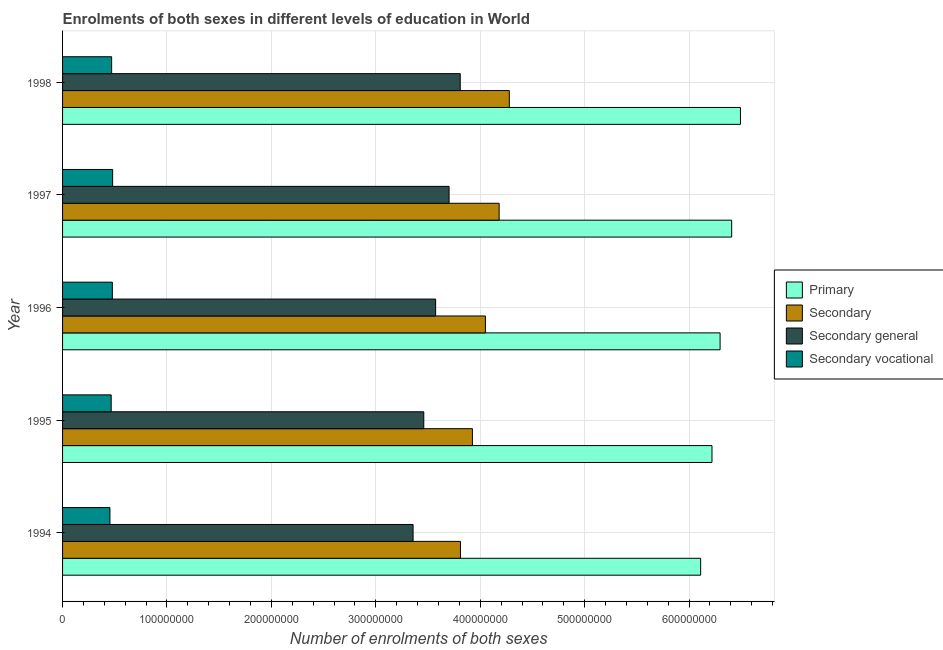Are the number of bars per tick equal to the number of legend labels?
Offer a very short reply. Yes. Are the number of bars on each tick of the Y-axis equal?
Offer a terse response. Yes. In how many cases, is the number of bars for a given year not equal to the number of legend labels?
Give a very brief answer. 0. What is the number of enrolments in primary education in 1996?
Provide a succinct answer. 6.30e+08. Across all years, what is the maximum number of enrolments in primary education?
Your answer should be compact. 6.49e+08. Across all years, what is the minimum number of enrolments in primary education?
Provide a succinct answer. 6.11e+08. What is the total number of enrolments in secondary vocational education in the graph?
Provide a short and direct response. 2.35e+08. What is the difference between the number of enrolments in primary education in 1994 and that in 1996?
Your answer should be compact. -1.86e+07. What is the difference between the number of enrolments in primary education in 1994 and the number of enrolments in secondary general education in 1998?
Provide a short and direct response. 2.30e+08. What is the average number of enrolments in secondary education per year?
Ensure brevity in your answer.  4.05e+08. In the year 1995, what is the difference between the number of enrolments in secondary education and number of enrolments in secondary general education?
Make the answer very short. 4.66e+07. In how many years, is the number of enrolments in secondary education greater than 260000000 ?
Keep it short and to the point. 5. Is the number of enrolments in secondary education in 1995 less than that in 1996?
Your answer should be very brief. Yes. What is the difference between the highest and the second highest number of enrolments in secondary vocational education?
Provide a short and direct response. 2.77e+05. What is the difference between the highest and the lowest number of enrolments in secondary general education?
Keep it short and to the point. 4.52e+07. In how many years, is the number of enrolments in secondary general education greater than the average number of enrolments in secondary general education taken over all years?
Give a very brief answer. 2. Is the sum of the number of enrolments in secondary general education in 1994 and 1997 greater than the maximum number of enrolments in secondary education across all years?
Give a very brief answer. Yes. Is it the case that in every year, the sum of the number of enrolments in secondary education and number of enrolments in secondary vocational education is greater than the sum of number of enrolments in secondary general education and number of enrolments in primary education?
Provide a succinct answer. Yes. What does the 4th bar from the top in 1994 represents?
Your answer should be very brief. Primary. What does the 3rd bar from the bottom in 1997 represents?
Your answer should be very brief. Secondary general. How many bars are there?
Your response must be concise. 20. Are all the bars in the graph horizontal?
Give a very brief answer. Yes. Are the values on the major ticks of X-axis written in scientific E-notation?
Your answer should be compact. No. Where does the legend appear in the graph?
Provide a succinct answer. Center right. How many legend labels are there?
Make the answer very short. 4. How are the legend labels stacked?
Your answer should be very brief. Vertical. What is the title of the graph?
Ensure brevity in your answer.  Enrolments of both sexes in different levels of education in World. Does "UNPBF" appear as one of the legend labels in the graph?
Provide a short and direct response. No. What is the label or title of the X-axis?
Make the answer very short. Number of enrolments of both sexes. What is the label or title of the Y-axis?
Provide a succinct answer. Year. What is the Number of enrolments of both sexes in Primary in 1994?
Your answer should be compact. 6.11e+08. What is the Number of enrolments of both sexes of Secondary in 1994?
Provide a short and direct response. 3.81e+08. What is the Number of enrolments of both sexes in Secondary general in 1994?
Ensure brevity in your answer.  3.36e+08. What is the Number of enrolments of both sexes of Secondary vocational in 1994?
Offer a terse response. 4.54e+07. What is the Number of enrolments of both sexes in Primary in 1995?
Offer a terse response. 6.22e+08. What is the Number of enrolments of both sexes of Secondary in 1995?
Your response must be concise. 3.92e+08. What is the Number of enrolments of both sexes of Secondary general in 1995?
Make the answer very short. 3.46e+08. What is the Number of enrolments of both sexes in Secondary vocational in 1995?
Make the answer very short. 4.66e+07. What is the Number of enrolments of both sexes of Primary in 1996?
Give a very brief answer. 6.30e+08. What is the Number of enrolments of both sexes of Secondary in 1996?
Your answer should be compact. 4.05e+08. What is the Number of enrolments of both sexes in Secondary general in 1996?
Offer a terse response. 3.57e+08. What is the Number of enrolments of both sexes in Secondary vocational in 1996?
Make the answer very short. 4.77e+07. What is the Number of enrolments of both sexes of Primary in 1997?
Offer a very short reply. 6.41e+08. What is the Number of enrolments of both sexes of Secondary in 1997?
Make the answer very short. 4.18e+08. What is the Number of enrolments of both sexes of Secondary general in 1997?
Give a very brief answer. 3.70e+08. What is the Number of enrolments of both sexes of Secondary vocational in 1997?
Keep it short and to the point. 4.80e+07. What is the Number of enrolments of both sexes of Primary in 1998?
Provide a short and direct response. 6.49e+08. What is the Number of enrolments of both sexes of Secondary in 1998?
Your answer should be compact. 4.28e+08. What is the Number of enrolments of both sexes in Secondary general in 1998?
Provide a short and direct response. 3.81e+08. What is the Number of enrolments of both sexes in Secondary vocational in 1998?
Your response must be concise. 4.70e+07. Across all years, what is the maximum Number of enrolments of both sexes in Primary?
Provide a short and direct response. 6.49e+08. Across all years, what is the maximum Number of enrolments of both sexes of Secondary?
Your answer should be compact. 4.28e+08. Across all years, what is the maximum Number of enrolments of both sexes in Secondary general?
Offer a very short reply. 3.81e+08. Across all years, what is the maximum Number of enrolments of both sexes in Secondary vocational?
Offer a terse response. 4.80e+07. Across all years, what is the minimum Number of enrolments of both sexes in Primary?
Ensure brevity in your answer.  6.11e+08. Across all years, what is the minimum Number of enrolments of both sexes in Secondary?
Your answer should be compact. 3.81e+08. Across all years, what is the minimum Number of enrolments of both sexes of Secondary general?
Offer a very short reply. 3.36e+08. Across all years, what is the minimum Number of enrolments of both sexes of Secondary vocational?
Make the answer very short. 4.54e+07. What is the total Number of enrolments of both sexes in Primary in the graph?
Provide a short and direct response. 3.15e+09. What is the total Number of enrolments of both sexes of Secondary in the graph?
Your answer should be very brief. 2.02e+09. What is the total Number of enrolments of both sexes in Secondary general in the graph?
Make the answer very short. 1.79e+09. What is the total Number of enrolments of both sexes in Secondary vocational in the graph?
Make the answer very short. 2.35e+08. What is the difference between the Number of enrolments of both sexes of Primary in 1994 and that in 1995?
Offer a very short reply. -1.08e+07. What is the difference between the Number of enrolments of both sexes in Secondary in 1994 and that in 1995?
Your answer should be compact. -1.14e+07. What is the difference between the Number of enrolments of both sexes in Secondary general in 1994 and that in 1995?
Offer a terse response. -1.02e+07. What is the difference between the Number of enrolments of both sexes of Secondary vocational in 1994 and that in 1995?
Give a very brief answer. -1.20e+06. What is the difference between the Number of enrolments of both sexes in Primary in 1994 and that in 1996?
Ensure brevity in your answer.  -1.86e+07. What is the difference between the Number of enrolments of both sexes in Secondary in 1994 and that in 1996?
Provide a short and direct response. -2.39e+07. What is the difference between the Number of enrolments of both sexes in Secondary general in 1994 and that in 1996?
Your answer should be compact. -2.16e+07. What is the difference between the Number of enrolments of both sexes of Secondary vocational in 1994 and that in 1996?
Provide a short and direct response. -2.31e+06. What is the difference between the Number of enrolments of both sexes of Primary in 1994 and that in 1997?
Provide a succinct answer. -2.97e+07. What is the difference between the Number of enrolments of both sexes of Secondary in 1994 and that in 1997?
Your answer should be compact. -3.71e+07. What is the difference between the Number of enrolments of both sexes of Secondary general in 1994 and that in 1997?
Offer a very short reply. -3.45e+07. What is the difference between the Number of enrolments of both sexes of Secondary vocational in 1994 and that in 1997?
Your answer should be compact. -2.59e+06. What is the difference between the Number of enrolments of both sexes in Primary in 1994 and that in 1998?
Offer a very short reply. -3.81e+07. What is the difference between the Number of enrolments of both sexes in Secondary in 1994 and that in 1998?
Give a very brief answer. -4.68e+07. What is the difference between the Number of enrolments of both sexes in Secondary general in 1994 and that in 1998?
Give a very brief answer. -4.52e+07. What is the difference between the Number of enrolments of both sexes of Secondary vocational in 1994 and that in 1998?
Offer a very short reply. -1.64e+06. What is the difference between the Number of enrolments of both sexes of Primary in 1995 and that in 1996?
Your response must be concise. -7.77e+06. What is the difference between the Number of enrolments of both sexes in Secondary in 1995 and that in 1996?
Offer a very short reply. -1.25e+07. What is the difference between the Number of enrolments of both sexes of Secondary general in 1995 and that in 1996?
Ensure brevity in your answer.  -1.14e+07. What is the difference between the Number of enrolments of both sexes of Secondary vocational in 1995 and that in 1996?
Ensure brevity in your answer.  -1.12e+06. What is the difference between the Number of enrolments of both sexes of Primary in 1995 and that in 1997?
Your response must be concise. -1.89e+07. What is the difference between the Number of enrolments of both sexes of Secondary in 1995 and that in 1997?
Make the answer very short. -2.56e+07. What is the difference between the Number of enrolments of both sexes of Secondary general in 1995 and that in 1997?
Your answer should be very brief. -2.42e+07. What is the difference between the Number of enrolments of both sexes of Secondary vocational in 1995 and that in 1997?
Your answer should be compact. -1.39e+06. What is the difference between the Number of enrolments of both sexes in Primary in 1995 and that in 1998?
Your response must be concise. -2.73e+07. What is the difference between the Number of enrolments of both sexes in Secondary in 1995 and that in 1998?
Your answer should be compact. -3.53e+07. What is the difference between the Number of enrolments of both sexes in Secondary general in 1995 and that in 1998?
Offer a very short reply. -3.49e+07. What is the difference between the Number of enrolments of both sexes in Secondary vocational in 1995 and that in 1998?
Give a very brief answer. -4.42e+05. What is the difference between the Number of enrolments of both sexes of Primary in 1996 and that in 1997?
Ensure brevity in your answer.  -1.11e+07. What is the difference between the Number of enrolments of both sexes of Secondary in 1996 and that in 1997?
Your answer should be very brief. -1.31e+07. What is the difference between the Number of enrolments of both sexes in Secondary general in 1996 and that in 1997?
Keep it short and to the point. -1.29e+07. What is the difference between the Number of enrolments of both sexes in Secondary vocational in 1996 and that in 1997?
Your answer should be very brief. -2.77e+05. What is the difference between the Number of enrolments of both sexes of Primary in 1996 and that in 1998?
Offer a terse response. -1.95e+07. What is the difference between the Number of enrolments of both sexes in Secondary in 1996 and that in 1998?
Ensure brevity in your answer.  -2.29e+07. What is the difference between the Number of enrolments of both sexes of Secondary general in 1996 and that in 1998?
Offer a terse response. -2.35e+07. What is the difference between the Number of enrolments of both sexes of Secondary vocational in 1996 and that in 1998?
Ensure brevity in your answer.  6.76e+05. What is the difference between the Number of enrolments of both sexes of Primary in 1997 and that in 1998?
Your answer should be very brief. -8.42e+06. What is the difference between the Number of enrolments of both sexes of Secondary in 1997 and that in 1998?
Give a very brief answer. -9.73e+06. What is the difference between the Number of enrolments of both sexes in Secondary general in 1997 and that in 1998?
Your answer should be very brief. -1.07e+07. What is the difference between the Number of enrolments of both sexes in Secondary vocational in 1997 and that in 1998?
Provide a short and direct response. 9.53e+05. What is the difference between the Number of enrolments of both sexes in Primary in 1994 and the Number of enrolments of both sexes in Secondary in 1995?
Your answer should be very brief. 2.19e+08. What is the difference between the Number of enrolments of both sexes in Primary in 1994 and the Number of enrolments of both sexes in Secondary general in 1995?
Ensure brevity in your answer.  2.65e+08. What is the difference between the Number of enrolments of both sexes in Primary in 1994 and the Number of enrolments of both sexes in Secondary vocational in 1995?
Keep it short and to the point. 5.65e+08. What is the difference between the Number of enrolments of both sexes in Secondary in 1994 and the Number of enrolments of both sexes in Secondary general in 1995?
Provide a succinct answer. 3.51e+07. What is the difference between the Number of enrolments of both sexes in Secondary in 1994 and the Number of enrolments of both sexes in Secondary vocational in 1995?
Provide a short and direct response. 3.34e+08. What is the difference between the Number of enrolments of both sexes in Secondary general in 1994 and the Number of enrolments of both sexes in Secondary vocational in 1995?
Provide a succinct answer. 2.89e+08. What is the difference between the Number of enrolments of both sexes in Primary in 1994 and the Number of enrolments of both sexes in Secondary in 1996?
Make the answer very short. 2.06e+08. What is the difference between the Number of enrolments of both sexes in Primary in 1994 and the Number of enrolments of both sexes in Secondary general in 1996?
Your response must be concise. 2.54e+08. What is the difference between the Number of enrolments of both sexes of Primary in 1994 and the Number of enrolments of both sexes of Secondary vocational in 1996?
Your answer should be compact. 5.63e+08. What is the difference between the Number of enrolments of both sexes of Secondary in 1994 and the Number of enrolments of both sexes of Secondary general in 1996?
Provide a short and direct response. 2.38e+07. What is the difference between the Number of enrolments of both sexes of Secondary in 1994 and the Number of enrolments of both sexes of Secondary vocational in 1996?
Make the answer very short. 3.33e+08. What is the difference between the Number of enrolments of both sexes of Secondary general in 1994 and the Number of enrolments of both sexes of Secondary vocational in 1996?
Give a very brief answer. 2.88e+08. What is the difference between the Number of enrolments of both sexes of Primary in 1994 and the Number of enrolments of both sexes of Secondary in 1997?
Make the answer very short. 1.93e+08. What is the difference between the Number of enrolments of both sexes of Primary in 1994 and the Number of enrolments of both sexes of Secondary general in 1997?
Keep it short and to the point. 2.41e+08. What is the difference between the Number of enrolments of both sexes of Primary in 1994 and the Number of enrolments of both sexes of Secondary vocational in 1997?
Ensure brevity in your answer.  5.63e+08. What is the difference between the Number of enrolments of both sexes in Secondary in 1994 and the Number of enrolments of both sexes in Secondary general in 1997?
Your answer should be compact. 1.09e+07. What is the difference between the Number of enrolments of both sexes of Secondary in 1994 and the Number of enrolments of both sexes of Secondary vocational in 1997?
Provide a succinct answer. 3.33e+08. What is the difference between the Number of enrolments of both sexes in Secondary general in 1994 and the Number of enrolments of both sexes in Secondary vocational in 1997?
Provide a succinct answer. 2.88e+08. What is the difference between the Number of enrolments of both sexes in Primary in 1994 and the Number of enrolments of both sexes in Secondary in 1998?
Your answer should be very brief. 1.83e+08. What is the difference between the Number of enrolments of both sexes of Primary in 1994 and the Number of enrolments of both sexes of Secondary general in 1998?
Your answer should be compact. 2.30e+08. What is the difference between the Number of enrolments of both sexes in Primary in 1994 and the Number of enrolments of both sexes in Secondary vocational in 1998?
Give a very brief answer. 5.64e+08. What is the difference between the Number of enrolments of both sexes in Secondary in 1994 and the Number of enrolments of both sexes in Secondary general in 1998?
Make the answer very short. 2.07e+05. What is the difference between the Number of enrolments of both sexes in Secondary in 1994 and the Number of enrolments of both sexes in Secondary vocational in 1998?
Keep it short and to the point. 3.34e+08. What is the difference between the Number of enrolments of both sexes of Secondary general in 1994 and the Number of enrolments of both sexes of Secondary vocational in 1998?
Give a very brief answer. 2.89e+08. What is the difference between the Number of enrolments of both sexes of Primary in 1995 and the Number of enrolments of both sexes of Secondary in 1996?
Keep it short and to the point. 2.17e+08. What is the difference between the Number of enrolments of both sexes in Primary in 1995 and the Number of enrolments of both sexes in Secondary general in 1996?
Provide a succinct answer. 2.65e+08. What is the difference between the Number of enrolments of both sexes of Primary in 1995 and the Number of enrolments of both sexes of Secondary vocational in 1996?
Ensure brevity in your answer.  5.74e+08. What is the difference between the Number of enrolments of both sexes in Secondary in 1995 and the Number of enrolments of both sexes in Secondary general in 1996?
Make the answer very short. 3.52e+07. What is the difference between the Number of enrolments of both sexes in Secondary in 1995 and the Number of enrolments of both sexes in Secondary vocational in 1996?
Provide a short and direct response. 3.45e+08. What is the difference between the Number of enrolments of both sexes of Secondary general in 1995 and the Number of enrolments of both sexes of Secondary vocational in 1996?
Make the answer very short. 2.98e+08. What is the difference between the Number of enrolments of both sexes of Primary in 1995 and the Number of enrolments of both sexes of Secondary in 1997?
Give a very brief answer. 2.04e+08. What is the difference between the Number of enrolments of both sexes of Primary in 1995 and the Number of enrolments of both sexes of Secondary general in 1997?
Provide a succinct answer. 2.52e+08. What is the difference between the Number of enrolments of both sexes in Primary in 1995 and the Number of enrolments of both sexes in Secondary vocational in 1997?
Give a very brief answer. 5.74e+08. What is the difference between the Number of enrolments of both sexes in Secondary in 1995 and the Number of enrolments of both sexes in Secondary general in 1997?
Offer a terse response. 2.23e+07. What is the difference between the Number of enrolments of both sexes of Secondary in 1995 and the Number of enrolments of both sexes of Secondary vocational in 1997?
Offer a terse response. 3.45e+08. What is the difference between the Number of enrolments of both sexes in Secondary general in 1995 and the Number of enrolments of both sexes in Secondary vocational in 1997?
Give a very brief answer. 2.98e+08. What is the difference between the Number of enrolments of both sexes in Primary in 1995 and the Number of enrolments of both sexes in Secondary in 1998?
Keep it short and to the point. 1.94e+08. What is the difference between the Number of enrolments of both sexes of Primary in 1995 and the Number of enrolments of both sexes of Secondary general in 1998?
Your answer should be compact. 2.41e+08. What is the difference between the Number of enrolments of both sexes of Primary in 1995 and the Number of enrolments of both sexes of Secondary vocational in 1998?
Your answer should be compact. 5.75e+08. What is the difference between the Number of enrolments of both sexes of Secondary in 1995 and the Number of enrolments of both sexes of Secondary general in 1998?
Provide a short and direct response. 1.17e+07. What is the difference between the Number of enrolments of both sexes of Secondary in 1995 and the Number of enrolments of both sexes of Secondary vocational in 1998?
Keep it short and to the point. 3.45e+08. What is the difference between the Number of enrolments of both sexes of Secondary general in 1995 and the Number of enrolments of both sexes of Secondary vocational in 1998?
Ensure brevity in your answer.  2.99e+08. What is the difference between the Number of enrolments of both sexes of Primary in 1996 and the Number of enrolments of both sexes of Secondary in 1997?
Ensure brevity in your answer.  2.12e+08. What is the difference between the Number of enrolments of both sexes of Primary in 1996 and the Number of enrolments of both sexes of Secondary general in 1997?
Make the answer very short. 2.60e+08. What is the difference between the Number of enrolments of both sexes in Primary in 1996 and the Number of enrolments of both sexes in Secondary vocational in 1997?
Offer a terse response. 5.82e+08. What is the difference between the Number of enrolments of both sexes of Secondary in 1996 and the Number of enrolments of both sexes of Secondary general in 1997?
Make the answer very short. 3.48e+07. What is the difference between the Number of enrolments of both sexes of Secondary in 1996 and the Number of enrolments of both sexes of Secondary vocational in 1997?
Your response must be concise. 3.57e+08. What is the difference between the Number of enrolments of both sexes of Secondary general in 1996 and the Number of enrolments of both sexes of Secondary vocational in 1997?
Keep it short and to the point. 3.09e+08. What is the difference between the Number of enrolments of both sexes in Primary in 1996 and the Number of enrolments of both sexes in Secondary in 1998?
Keep it short and to the point. 2.02e+08. What is the difference between the Number of enrolments of both sexes of Primary in 1996 and the Number of enrolments of both sexes of Secondary general in 1998?
Your response must be concise. 2.49e+08. What is the difference between the Number of enrolments of both sexes of Primary in 1996 and the Number of enrolments of both sexes of Secondary vocational in 1998?
Keep it short and to the point. 5.83e+08. What is the difference between the Number of enrolments of both sexes of Secondary in 1996 and the Number of enrolments of both sexes of Secondary general in 1998?
Your answer should be compact. 2.41e+07. What is the difference between the Number of enrolments of both sexes of Secondary in 1996 and the Number of enrolments of both sexes of Secondary vocational in 1998?
Provide a short and direct response. 3.58e+08. What is the difference between the Number of enrolments of both sexes in Secondary general in 1996 and the Number of enrolments of both sexes in Secondary vocational in 1998?
Make the answer very short. 3.10e+08. What is the difference between the Number of enrolments of both sexes of Primary in 1997 and the Number of enrolments of both sexes of Secondary in 1998?
Make the answer very short. 2.13e+08. What is the difference between the Number of enrolments of both sexes of Primary in 1997 and the Number of enrolments of both sexes of Secondary general in 1998?
Give a very brief answer. 2.60e+08. What is the difference between the Number of enrolments of both sexes of Primary in 1997 and the Number of enrolments of both sexes of Secondary vocational in 1998?
Offer a terse response. 5.94e+08. What is the difference between the Number of enrolments of both sexes of Secondary in 1997 and the Number of enrolments of both sexes of Secondary general in 1998?
Provide a succinct answer. 3.73e+07. What is the difference between the Number of enrolments of both sexes in Secondary in 1997 and the Number of enrolments of both sexes in Secondary vocational in 1998?
Your answer should be compact. 3.71e+08. What is the difference between the Number of enrolments of both sexes in Secondary general in 1997 and the Number of enrolments of both sexes in Secondary vocational in 1998?
Give a very brief answer. 3.23e+08. What is the average Number of enrolments of both sexes of Primary per year?
Your answer should be very brief. 6.31e+08. What is the average Number of enrolments of both sexes in Secondary per year?
Your response must be concise. 4.05e+08. What is the average Number of enrolments of both sexes of Secondary general per year?
Provide a succinct answer. 3.58e+08. What is the average Number of enrolments of both sexes of Secondary vocational per year?
Keep it short and to the point. 4.69e+07. In the year 1994, what is the difference between the Number of enrolments of both sexes in Primary and Number of enrolments of both sexes in Secondary?
Offer a very short reply. 2.30e+08. In the year 1994, what is the difference between the Number of enrolments of both sexes in Primary and Number of enrolments of both sexes in Secondary general?
Make the answer very short. 2.75e+08. In the year 1994, what is the difference between the Number of enrolments of both sexes of Primary and Number of enrolments of both sexes of Secondary vocational?
Ensure brevity in your answer.  5.66e+08. In the year 1994, what is the difference between the Number of enrolments of both sexes in Secondary and Number of enrolments of both sexes in Secondary general?
Your response must be concise. 4.54e+07. In the year 1994, what is the difference between the Number of enrolments of both sexes of Secondary and Number of enrolments of both sexes of Secondary vocational?
Your answer should be very brief. 3.36e+08. In the year 1994, what is the difference between the Number of enrolments of both sexes of Secondary general and Number of enrolments of both sexes of Secondary vocational?
Offer a terse response. 2.90e+08. In the year 1995, what is the difference between the Number of enrolments of both sexes in Primary and Number of enrolments of both sexes in Secondary?
Offer a terse response. 2.29e+08. In the year 1995, what is the difference between the Number of enrolments of both sexes in Primary and Number of enrolments of both sexes in Secondary general?
Offer a very short reply. 2.76e+08. In the year 1995, what is the difference between the Number of enrolments of both sexes of Primary and Number of enrolments of both sexes of Secondary vocational?
Keep it short and to the point. 5.75e+08. In the year 1995, what is the difference between the Number of enrolments of both sexes in Secondary and Number of enrolments of both sexes in Secondary general?
Your answer should be compact. 4.66e+07. In the year 1995, what is the difference between the Number of enrolments of both sexes of Secondary and Number of enrolments of both sexes of Secondary vocational?
Your answer should be very brief. 3.46e+08. In the year 1995, what is the difference between the Number of enrolments of both sexes in Secondary general and Number of enrolments of both sexes in Secondary vocational?
Make the answer very short. 2.99e+08. In the year 1996, what is the difference between the Number of enrolments of both sexes of Primary and Number of enrolments of both sexes of Secondary?
Provide a short and direct response. 2.25e+08. In the year 1996, what is the difference between the Number of enrolments of both sexes of Primary and Number of enrolments of both sexes of Secondary general?
Your response must be concise. 2.72e+08. In the year 1996, what is the difference between the Number of enrolments of both sexes in Primary and Number of enrolments of both sexes in Secondary vocational?
Provide a short and direct response. 5.82e+08. In the year 1996, what is the difference between the Number of enrolments of both sexes in Secondary and Number of enrolments of both sexes in Secondary general?
Offer a very short reply. 4.77e+07. In the year 1996, what is the difference between the Number of enrolments of both sexes of Secondary and Number of enrolments of both sexes of Secondary vocational?
Provide a short and direct response. 3.57e+08. In the year 1996, what is the difference between the Number of enrolments of both sexes in Secondary general and Number of enrolments of both sexes in Secondary vocational?
Keep it short and to the point. 3.10e+08. In the year 1997, what is the difference between the Number of enrolments of both sexes of Primary and Number of enrolments of both sexes of Secondary?
Offer a terse response. 2.23e+08. In the year 1997, what is the difference between the Number of enrolments of both sexes in Primary and Number of enrolments of both sexes in Secondary general?
Offer a terse response. 2.71e+08. In the year 1997, what is the difference between the Number of enrolments of both sexes of Primary and Number of enrolments of both sexes of Secondary vocational?
Make the answer very short. 5.93e+08. In the year 1997, what is the difference between the Number of enrolments of both sexes of Secondary and Number of enrolments of both sexes of Secondary general?
Your response must be concise. 4.80e+07. In the year 1997, what is the difference between the Number of enrolments of both sexes in Secondary and Number of enrolments of both sexes in Secondary vocational?
Your response must be concise. 3.70e+08. In the year 1997, what is the difference between the Number of enrolments of both sexes of Secondary general and Number of enrolments of both sexes of Secondary vocational?
Provide a succinct answer. 3.22e+08. In the year 1998, what is the difference between the Number of enrolments of both sexes of Primary and Number of enrolments of both sexes of Secondary?
Offer a very short reply. 2.21e+08. In the year 1998, what is the difference between the Number of enrolments of both sexes of Primary and Number of enrolments of both sexes of Secondary general?
Make the answer very short. 2.68e+08. In the year 1998, what is the difference between the Number of enrolments of both sexes of Primary and Number of enrolments of both sexes of Secondary vocational?
Your answer should be compact. 6.02e+08. In the year 1998, what is the difference between the Number of enrolments of both sexes in Secondary and Number of enrolments of both sexes in Secondary general?
Provide a succinct answer. 4.70e+07. In the year 1998, what is the difference between the Number of enrolments of both sexes in Secondary and Number of enrolments of both sexes in Secondary vocational?
Provide a short and direct response. 3.81e+08. In the year 1998, what is the difference between the Number of enrolments of both sexes in Secondary general and Number of enrolments of both sexes in Secondary vocational?
Keep it short and to the point. 3.34e+08. What is the ratio of the Number of enrolments of both sexes of Primary in 1994 to that in 1995?
Your response must be concise. 0.98. What is the ratio of the Number of enrolments of both sexes of Secondary in 1994 to that in 1995?
Offer a very short reply. 0.97. What is the ratio of the Number of enrolments of both sexes in Secondary general in 1994 to that in 1995?
Provide a succinct answer. 0.97. What is the ratio of the Number of enrolments of both sexes of Secondary vocational in 1994 to that in 1995?
Your response must be concise. 0.97. What is the ratio of the Number of enrolments of both sexes of Primary in 1994 to that in 1996?
Offer a very short reply. 0.97. What is the ratio of the Number of enrolments of both sexes of Secondary in 1994 to that in 1996?
Ensure brevity in your answer.  0.94. What is the ratio of the Number of enrolments of both sexes in Secondary general in 1994 to that in 1996?
Offer a terse response. 0.94. What is the ratio of the Number of enrolments of both sexes in Secondary vocational in 1994 to that in 1996?
Ensure brevity in your answer.  0.95. What is the ratio of the Number of enrolments of both sexes of Primary in 1994 to that in 1997?
Provide a succinct answer. 0.95. What is the ratio of the Number of enrolments of both sexes of Secondary in 1994 to that in 1997?
Ensure brevity in your answer.  0.91. What is the ratio of the Number of enrolments of both sexes of Secondary general in 1994 to that in 1997?
Offer a terse response. 0.91. What is the ratio of the Number of enrolments of both sexes of Secondary vocational in 1994 to that in 1997?
Offer a very short reply. 0.95. What is the ratio of the Number of enrolments of both sexes in Primary in 1994 to that in 1998?
Your answer should be very brief. 0.94. What is the ratio of the Number of enrolments of both sexes of Secondary in 1994 to that in 1998?
Offer a terse response. 0.89. What is the ratio of the Number of enrolments of both sexes in Secondary general in 1994 to that in 1998?
Your response must be concise. 0.88. What is the ratio of the Number of enrolments of both sexes in Secondary vocational in 1994 to that in 1998?
Make the answer very short. 0.97. What is the ratio of the Number of enrolments of both sexes of Secondary in 1995 to that in 1996?
Give a very brief answer. 0.97. What is the ratio of the Number of enrolments of both sexes of Secondary general in 1995 to that in 1996?
Offer a terse response. 0.97. What is the ratio of the Number of enrolments of both sexes in Secondary vocational in 1995 to that in 1996?
Make the answer very short. 0.98. What is the ratio of the Number of enrolments of both sexes of Primary in 1995 to that in 1997?
Offer a terse response. 0.97. What is the ratio of the Number of enrolments of both sexes in Secondary in 1995 to that in 1997?
Provide a short and direct response. 0.94. What is the ratio of the Number of enrolments of both sexes of Secondary general in 1995 to that in 1997?
Your response must be concise. 0.93. What is the ratio of the Number of enrolments of both sexes in Secondary vocational in 1995 to that in 1997?
Offer a terse response. 0.97. What is the ratio of the Number of enrolments of both sexes in Primary in 1995 to that in 1998?
Keep it short and to the point. 0.96. What is the ratio of the Number of enrolments of both sexes of Secondary in 1995 to that in 1998?
Your answer should be compact. 0.92. What is the ratio of the Number of enrolments of both sexes in Secondary general in 1995 to that in 1998?
Provide a short and direct response. 0.91. What is the ratio of the Number of enrolments of both sexes in Secondary vocational in 1995 to that in 1998?
Provide a succinct answer. 0.99. What is the ratio of the Number of enrolments of both sexes in Primary in 1996 to that in 1997?
Provide a short and direct response. 0.98. What is the ratio of the Number of enrolments of both sexes in Secondary in 1996 to that in 1997?
Provide a short and direct response. 0.97. What is the ratio of the Number of enrolments of both sexes of Secondary general in 1996 to that in 1997?
Provide a short and direct response. 0.97. What is the ratio of the Number of enrolments of both sexes in Primary in 1996 to that in 1998?
Provide a succinct answer. 0.97. What is the ratio of the Number of enrolments of both sexes of Secondary in 1996 to that in 1998?
Give a very brief answer. 0.95. What is the ratio of the Number of enrolments of both sexes of Secondary general in 1996 to that in 1998?
Your answer should be compact. 0.94. What is the ratio of the Number of enrolments of both sexes in Secondary vocational in 1996 to that in 1998?
Offer a very short reply. 1.01. What is the ratio of the Number of enrolments of both sexes in Primary in 1997 to that in 1998?
Ensure brevity in your answer.  0.99. What is the ratio of the Number of enrolments of both sexes in Secondary in 1997 to that in 1998?
Your answer should be compact. 0.98. What is the ratio of the Number of enrolments of both sexes in Secondary general in 1997 to that in 1998?
Your response must be concise. 0.97. What is the ratio of the Number of enrolments of both sexes of Secondary vocational in 1997 to that in 1998?
Provide a succinct answer. 1.02. What is the difference between the highest and the second highest Number of enrolments of both sexes in Primary?
Make the answer very short. 8.42e+06. What is the difference between the highest and the second highest Number of enrolments of both sexes in Secondary?
Ensure brevity in your answer.  9.73e+06. What is the difference between the highest and the second highest Number of enrolments of both sexes in Secondary general?
Give a very brief answer. 1.07e+07. What is the difference between the highest and the second highest Number of enrolments of both sexes in Secondary vocational?
Provide a succinct answer. 2.77e+05. What is the difference between the highest and the lowest Number of enrolments of both sexes of Primary?
Your answer should be very brief. 3.81e+07. What is the difference between the highest and the lowest Number of enrolments of both sexes of Secondary?
Your response must be concise. 4.68e+07. What is the difference between the highest and the lowest Number of enrolments of both sexes of Secondary general?
Ensure brevity in your answer.  4.52e+07. What is the difference between the highest and the lowest Number of enrolments of both sexes of Secondary vocational?
Offer a very short reply. 2.59e+06. 